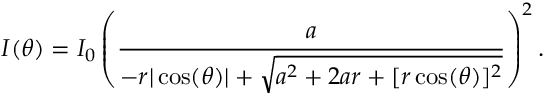Convert formula to latex. <formula><loc_0><loc_0><loc_500><loc_500>I ( \theta ) = I _ { 0 } \left ( \frac { a } { - r | \cos ( \theta ) | + \sqrt { a ^ { 2 } + 2 a r + [ r \cos ( \theta ) ] ^ { 2 } } } \right ) ^ { 2 } .</formula> 